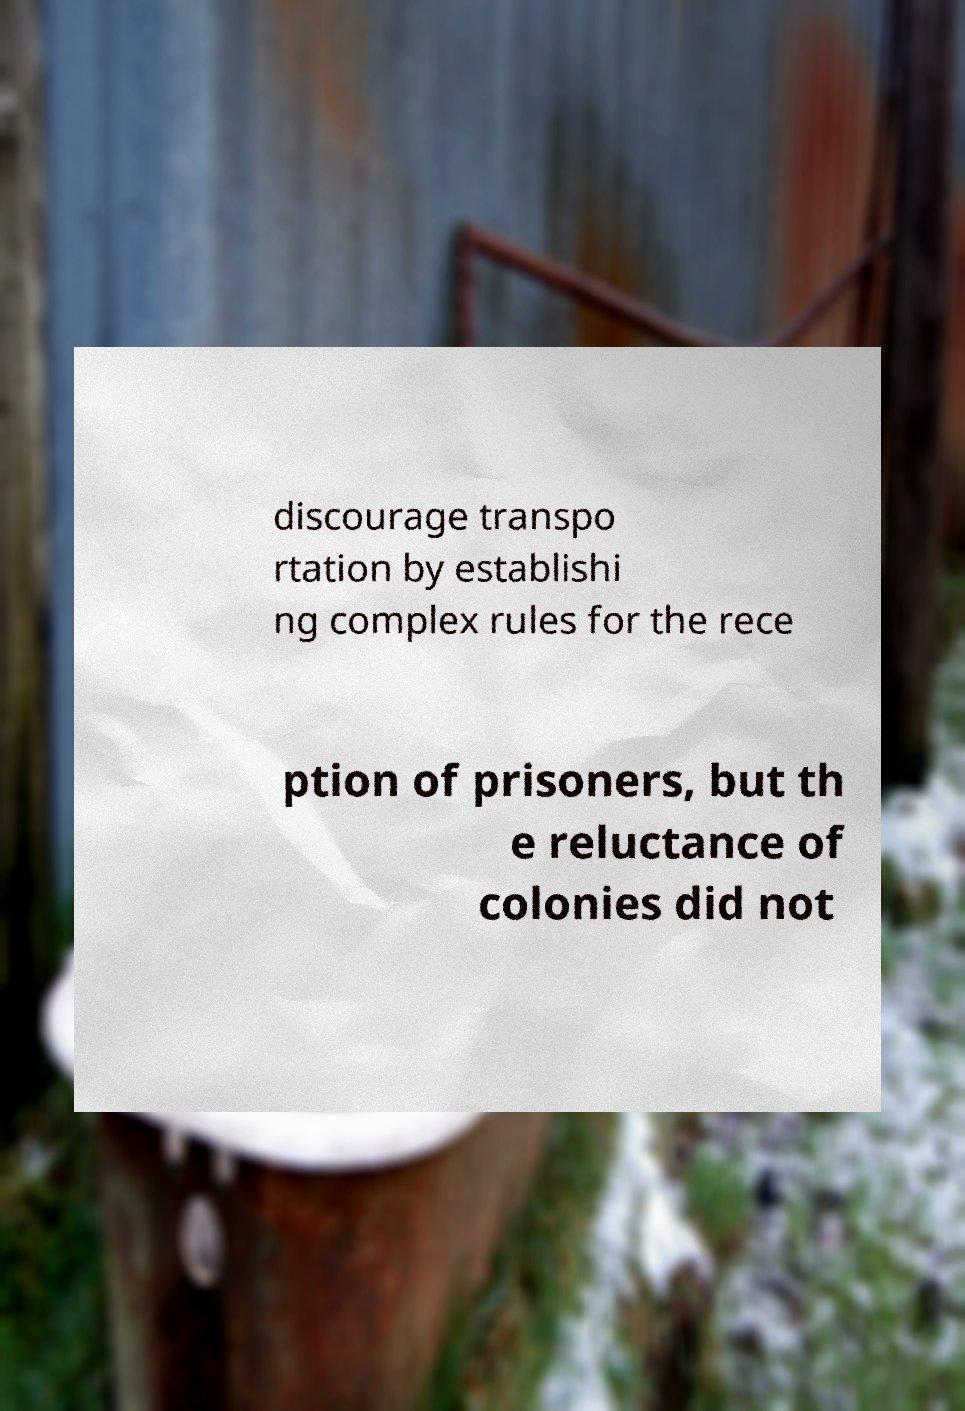What messages or text are displayed in this image? I need them in a readable, typed format. discourage transpo rtation by establishi ng complex rules for the rece ption of prisoners, but th e reluctance of colonies did not 